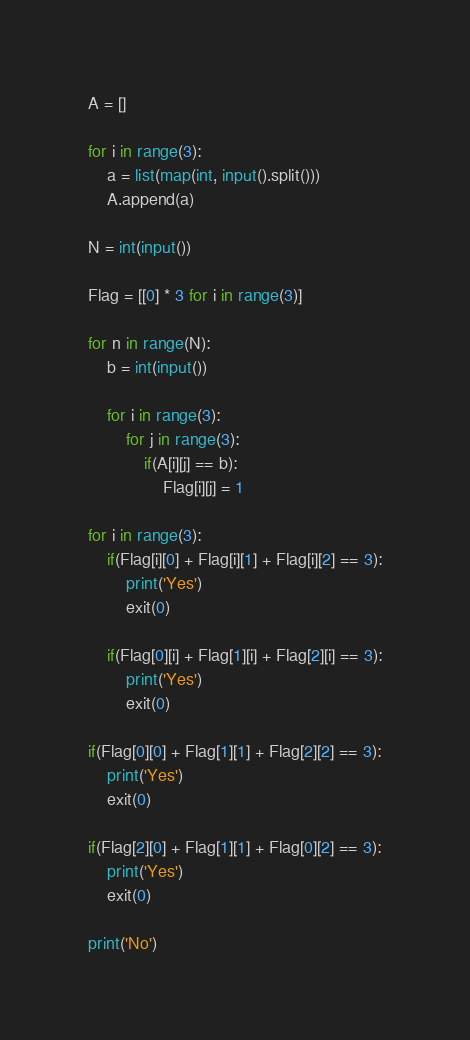Convert code to text. <code><loc_0><loc_0><loc_500><loc_500><_Python_>

A = []

for i in range(3):
	a = list(map(int, input().split()))
	A.append(a)

N = int(input())

Flag = [[0] * 3 for i in range(3)]

for n in range(N):
	b = int(input())

	for i in range(3):
		for j in range(3):
			if(A[i][j] == b):
				Flag[i][j] = 1

for i in range(3):
	if(Flag[i][0] + Flag[i][1] + Flag[i][2] == 3):
		print('Yes')
		exit(0)

	if(Flag[0][i] + Flag[1][i] + Flag[2][i] == 3):
		print('Yes')
		exit(0)

if(Flag[0][0] + Flag[1][1] + Flag[2][2] == 3):
	print('Yes')
	exit(0)

if(Flag[2][0] + Flag[1][1] + Flag[0][2] == 3):
	print('Yes')
	exit(0)

print('No')</code> 